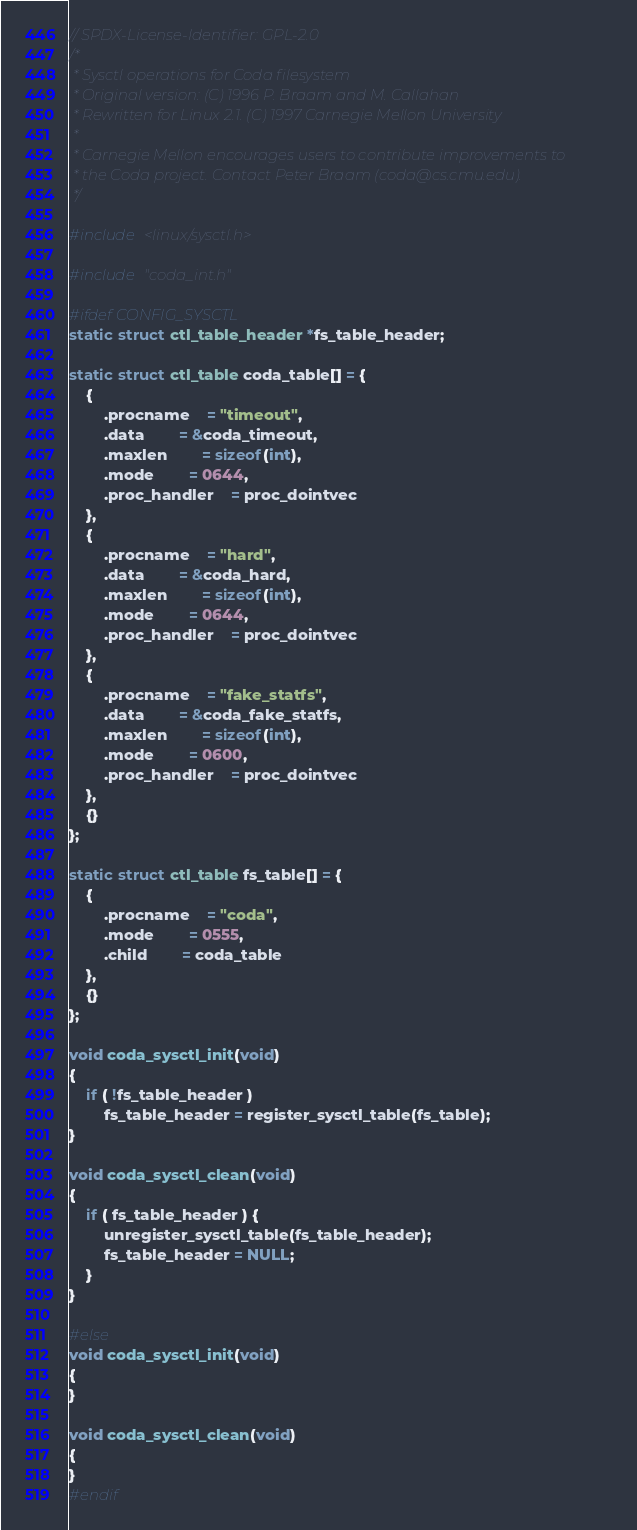<code> <loc_0><loc_0><loc_500><loc_500><_C_>// SPDX-License-Identifier: GPL-2.0
/*
 * Sysctl operations for Coda filesystem
 * Original version: (C) 1996 P. Braam and M. Callahan
 * Rewritten for Linux 2.1. (C) 1997 Carnegie Mellon University
 * 
 * Carnegie Mellon encourages users to contribute improvements to
 * the Coda project. Contact Peter Braam (coda@cs.cmu.edu).
 */

#include <linux/sysctl.h>

#include "coda_int.h"

#ifdef CONFIG_SYSCTL
static struct ctl_table_header *fs_table_header;

static struct ctl_table coda_table[] = {
	{
		.procname	= "timeout",
		.data		= &coda_timeout,
		.maxlen		= sizeof(int),
		.mode		= 0644,
		.proc_handler	= proc_dointvec
	},
	{
		.procname	= "hard",
		.data		= &coda_hard,
		.maxlen		= sizeof(int),
		.mode		= 0644,
		.proc_handler	= proc_dointvec
	},
	{
		.procname	= "fake_statfs",
		.data		= &coda_fake_statfs,
		.maxlen		= sizeof(int),
		.mode		= 0600,
		.proc_handler	= proc_dointvec
	},
	{}
};

static struct ctl_table fs_table[] = {
	{
		.procname	= "coda",
		.mode		= 0555,
		.child		= coda_table
	},
	{}
};

void coda_sysctl_init(void)
{
	if ( !fs_table_header )
		fs_table_header = register_sysctl_table(fs_table);
}

void coda_sysctl_clean(void)
{
	if ( fs_table_header ) {
		unregister_sysctl_table(fs_table_header);
		fs_table_header = NULL;
	}
}

#else
void coda_sysctl_init(void)
{
}

void coda_sysctl_clean(void)
{
}
#endif
</code> 